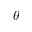<formula> <loc_0><loc_0><loc_500><loc_500>\theta</formula> 